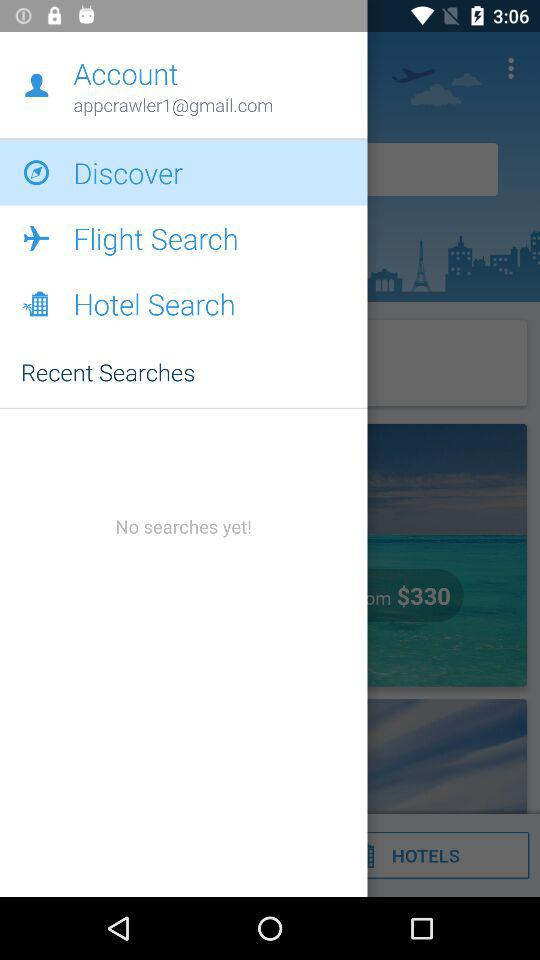What Gmail address is used? The Gmail address used is appcrawler1@gmail.com. 